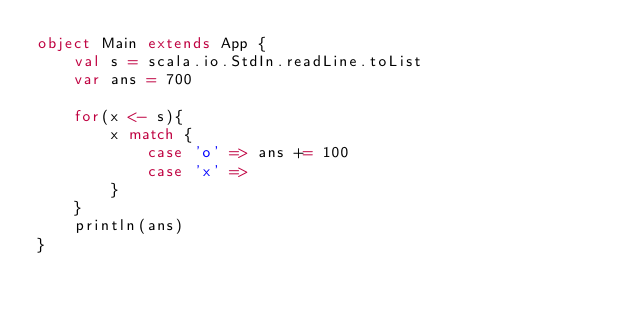Convert code to text. <code><loc_0><loc_0><loc_500><loc_500><_Scala_>object Main extends App {
	val s = scala.io.StdIn.readLine.toList
	var ans = 700

	for(x <- s){
		x match {
			case 'o' => ans += 100
			case 'x' => 
		}
	}
	println(ans)
}
</code> 